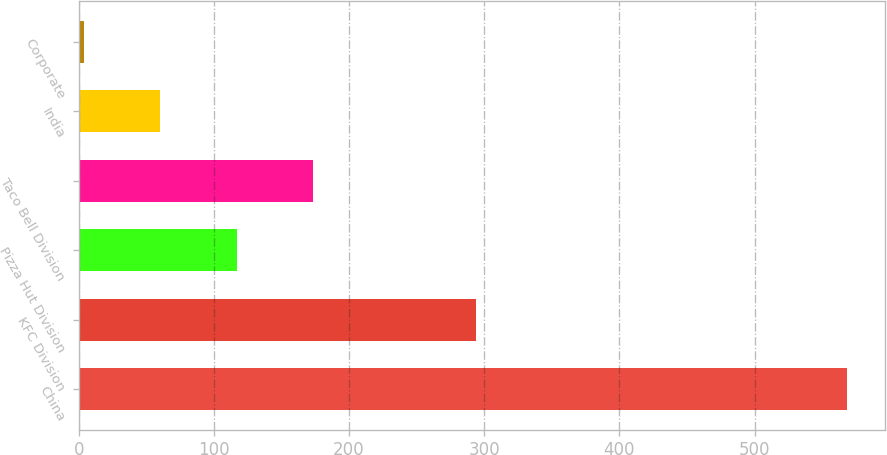Convert chart. <chart><loc_0><loc_0><loc_500><loc_500><bar_chart><fcel>China<fcel>KFC Division<fcel>Pizza Hut Division<fcel>Taco Bell Division<fcel>India<fcel>Corporate<nl><fcel>568<fcel>294<fcel>116.8<fcel>173.2<fcel>60.4<fcel>4<nl></chart> 